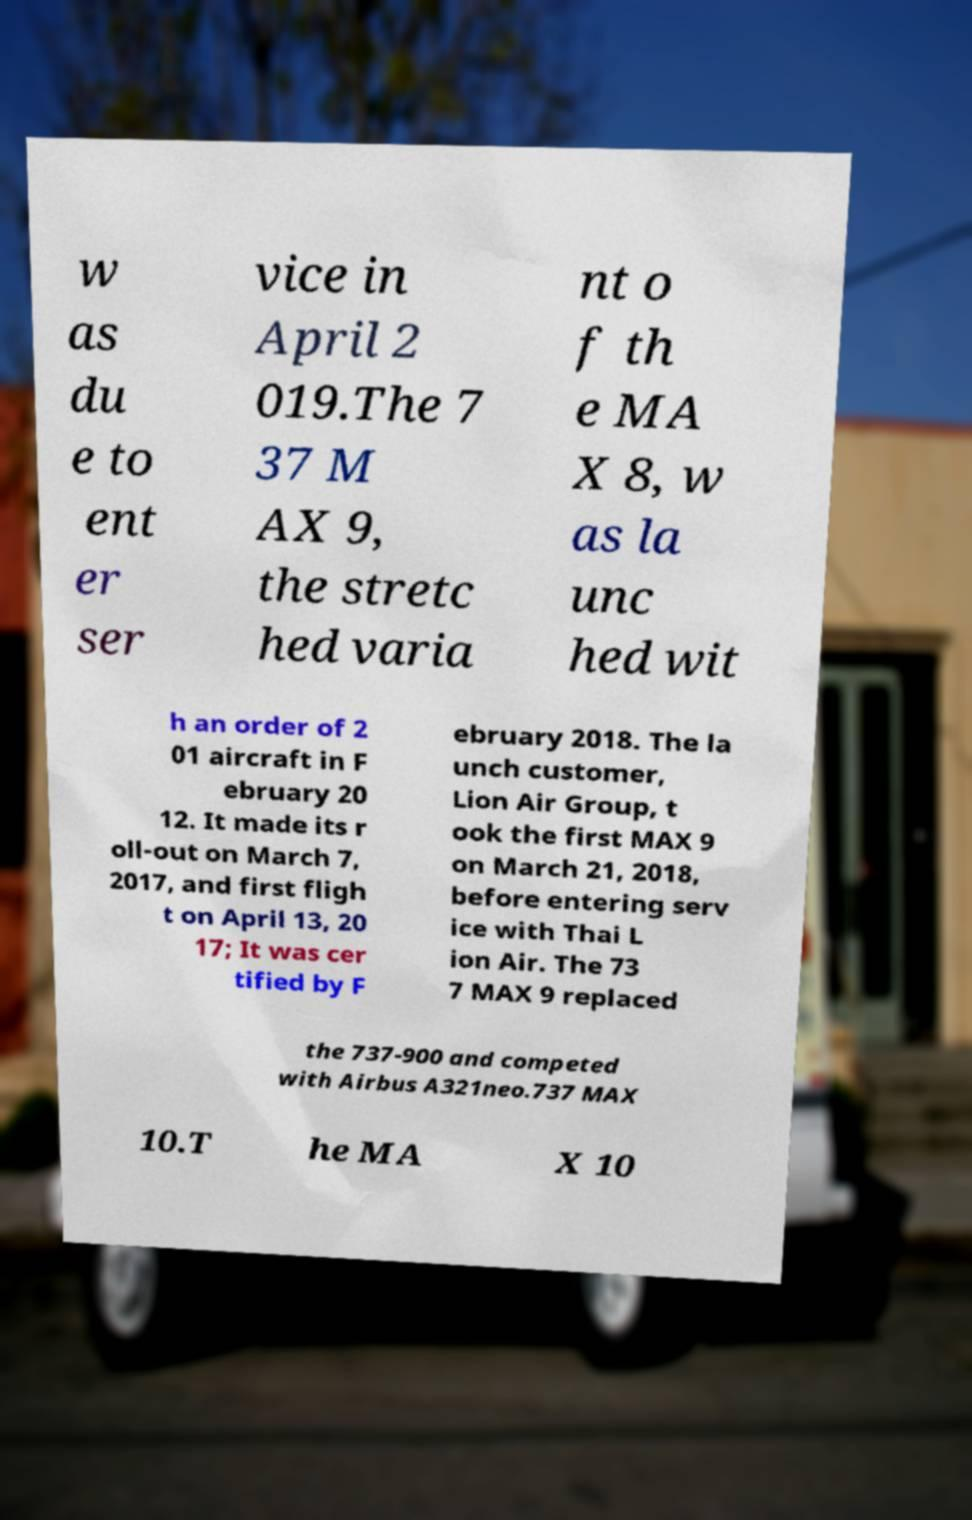I need the written content from this picture converted into text. Can you do that? w as du e to ent er ser vice in April 2 019.The 7 37 M AX 9, the stretc hed varia nt o f th e MA X 8, w as la unc hed wit h an order of 2 01 aircraft in F ebruary 20 12. It made its r oll-out on March 7, 2017, and first fligh t on April 13, 20 17; It was cer tified by F ebruary 2018. The la unch customer, Lion Air Group, t ook the first MAX 9 on March 21, 2018, before entering serv ice with Thai L ion Air. The 73 7 MAX 9 replaced the 737-900 and competed with Airbus A321neo.737 MAX 10.T he MA X 10 